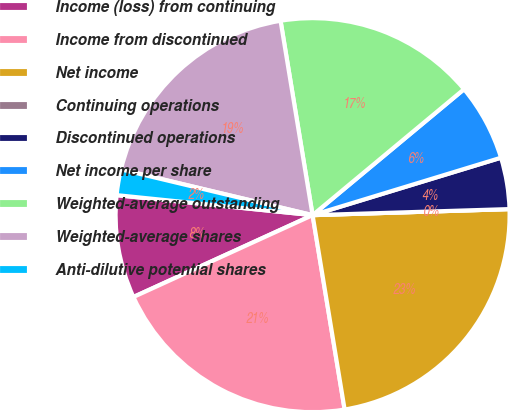Convert chart. <chart><loc_0><loc_0><loc_500><loc_500><pie_chart><fcel>Income (loss) from continuing<fcel>Income from discontinued<fcel>Net income<fcel>Continuing operations<fcel>Discontinued operations<fcel>Net income per share<fcel>Weighted-average outstanding<fcel>Weighted-average shares<fcel>Anti-dilutive potential shares<nl><fcel>8.44%<fcel>20.78%<fcel>22.89%<fcel>0.0%<fcel>4.22%<fcel>6.33%<fcel>16.56%<fcel>18.67%<fcel>2.11%<nl></chart> 